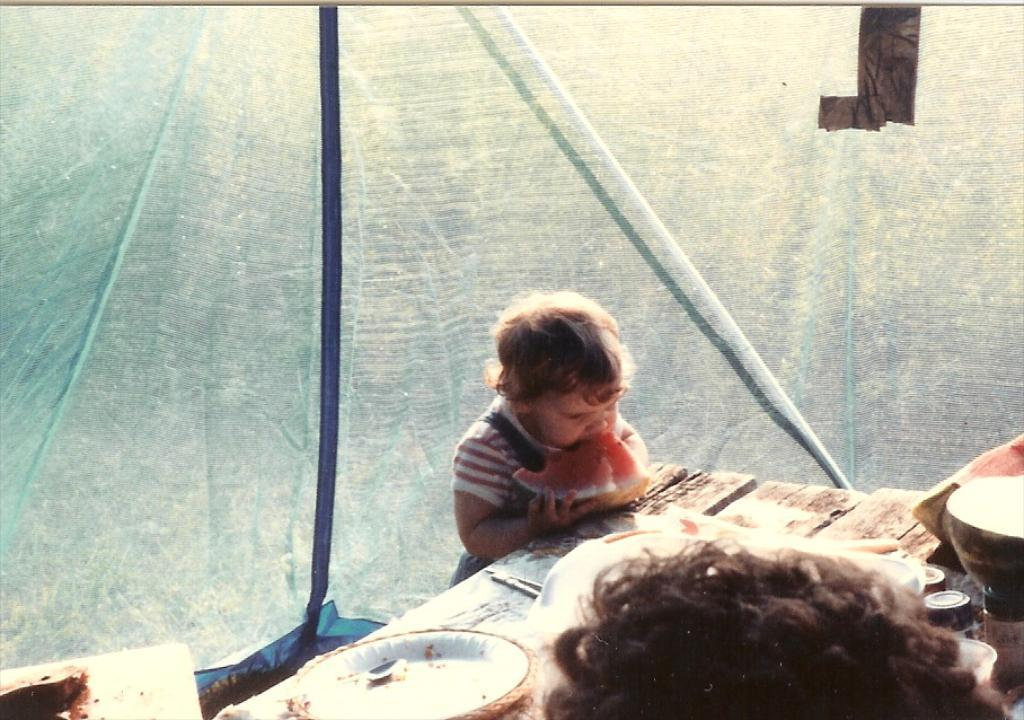Who is the main subject in the image? There is a small girl in the image. What is the girl doing in the image? The girl is eating watermelon. What can be seen on the table in the image? There are white plates on a table in the image. What is visible in the background of the image? There is a curtain tent in the background of the image. What type of apple is the girl holding in the image? There is no apple present in the image; the girl is eating watermelon. What is the girl's body condition in the image? The image does not provide information about the girl's body condition. 